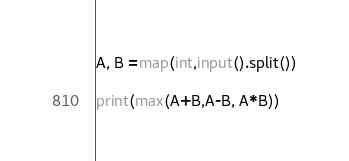Convert code to text. <code><loc_0><loc_0><loc_500><loc_500><_Python_>A, B =map(int,input().split())

print(max(A+B,A-B, A*B))</code> 